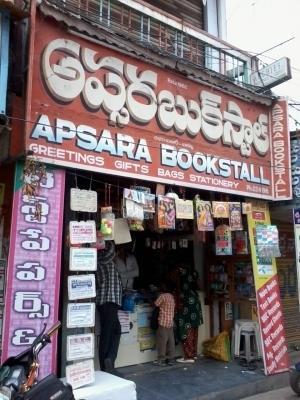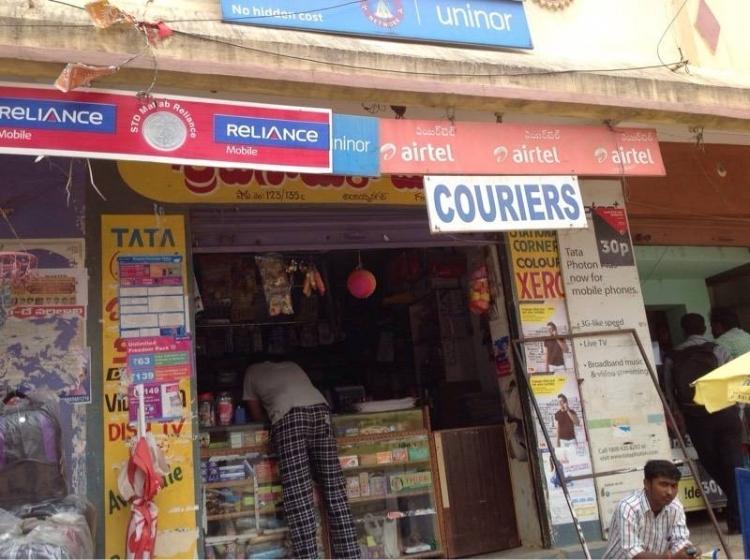The first image is the image on the left, the second image is the image on the right. Given the left and right images, does the statement "No people are shown in front of the bookshop in the image on the right." hold true? Answer yes or no. No. The first image is the image on the left, the second image is the image on the right. Assess this claim about the two images: "A person is sitting on the ground in front of a store in the right image.". Correct or not? Answer yes or no. Yes. 